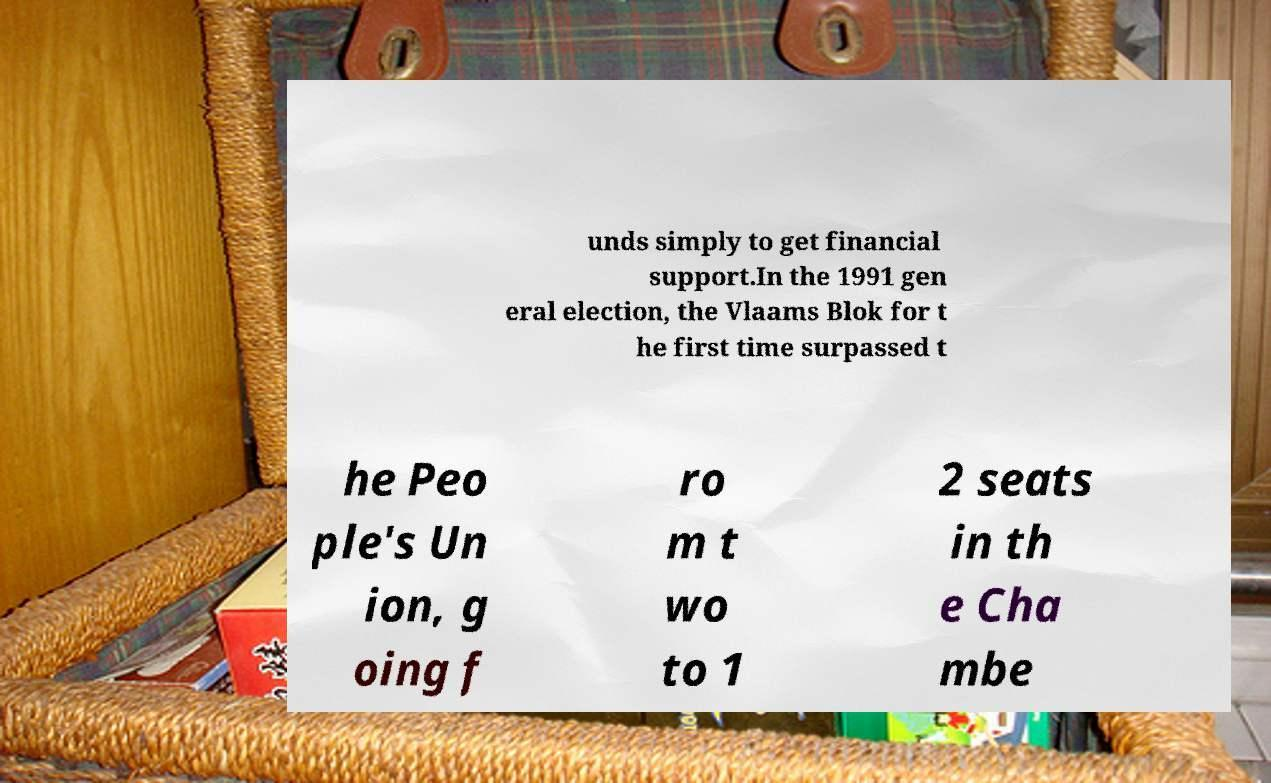For documentation purposes, I need the text within this image transcribed. Could you provide that? unds simply to get financial support.In the 1991 gen eral election, the Vlaams Blok for t he first time surpassed t he Peo ple's Un ion, g oing f ro m t wo to 1 2 seats in th e Cha mbe 